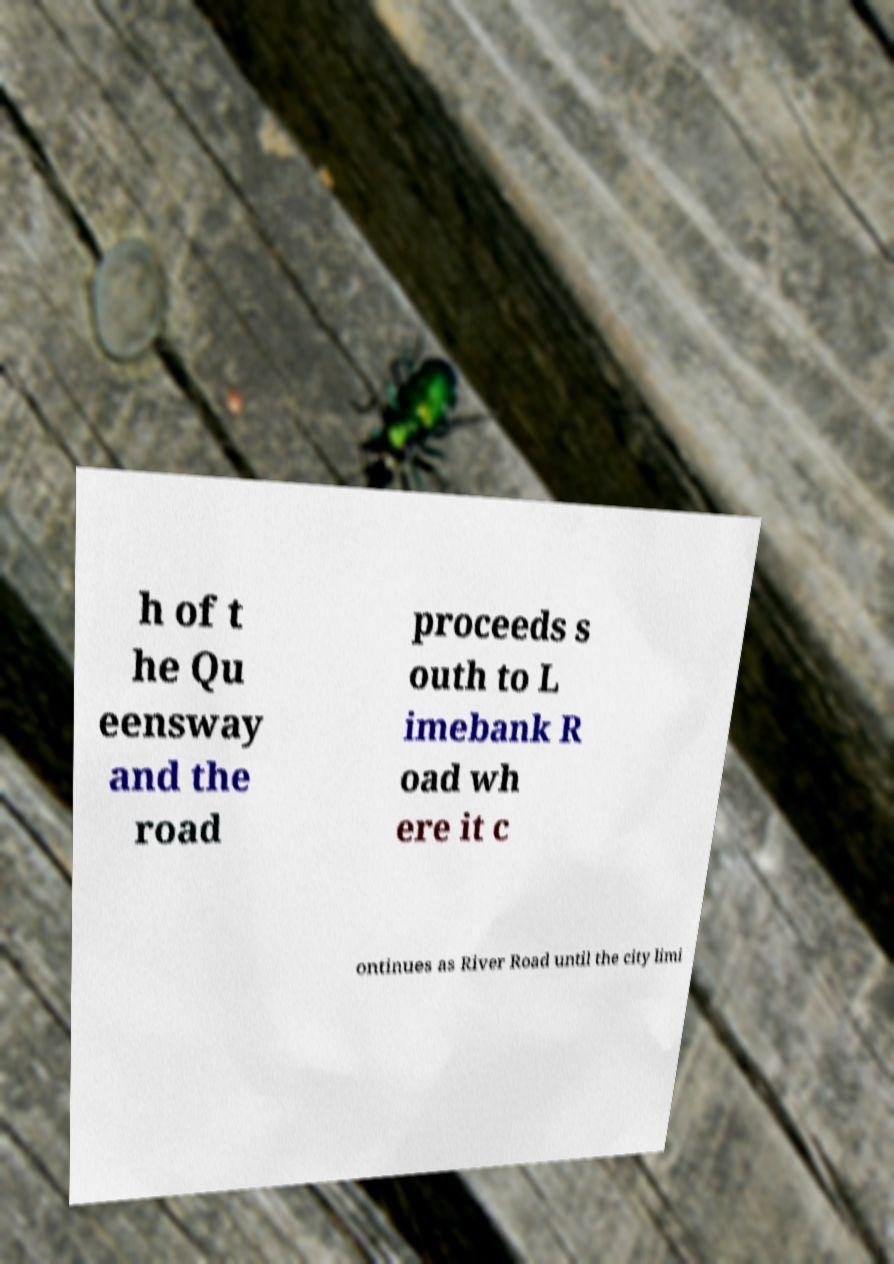What messages or text are displayed in this image? I need them in a readable, typed format. h of t he Qu eensway and the road proceeds s outh to L imebank R oad wh ere it c ontinues as River Road until the city limi 